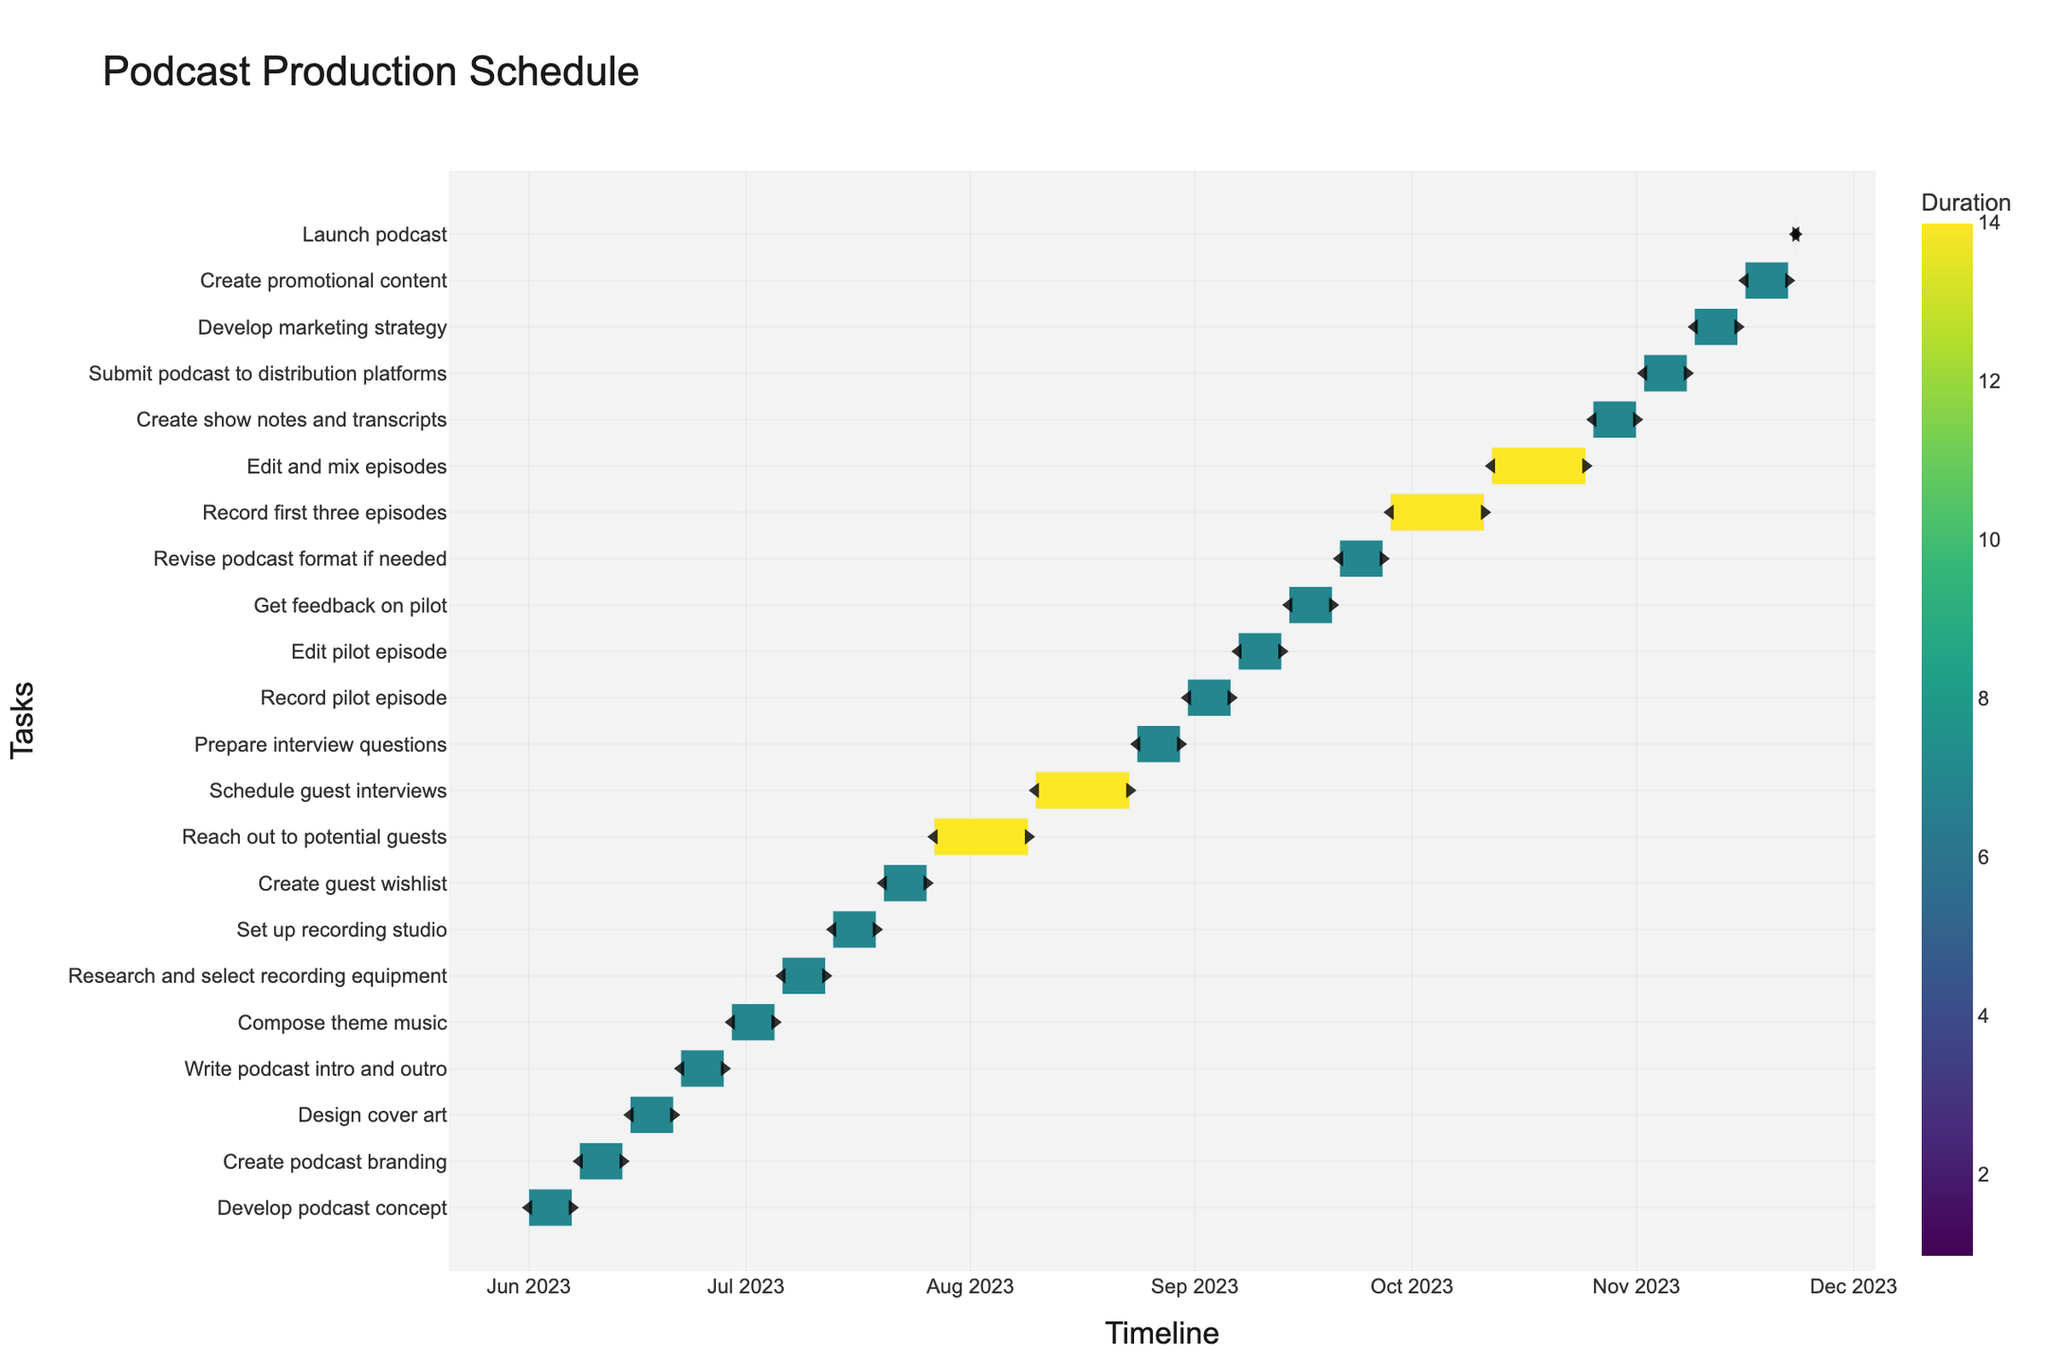What is the title of the chart? The title is displayed at the top of the Gantt chart, showing the main purpose of the chart, which in this case is related to a podcast production schedule.
Answer: Podcast Production Schedule How long is the "Develop podcast concept" phase? The duration can be calculated using the start and end dates of the task. For "Develop podcast concept," it starts on June 1, 2023, and ends on June 7, 2023. So the duration is 7 days.
Answer: 7 days What is the color scale used in the chart? The chart uses a sequential color scale named Viridis, typically ranging from dark blue to bright yellow, representing the duration of tasks.
Answer: Viridis Find the task that takes the longest time. How many days does it take? To find the task with the longest duration, we need to compare the durations of all tasks. "Reach out to potential guests" takes the longest duration starting from July 27, 2023, to August 9, 2023, which is 14 days.
Answer: 14 days Compare the duration of "Record pilot episode" and "Edit pilot episode." Which one takes longer, and by how many days? "Record pilot episode" takes 7 days (August 31, 2023, to September 6, 2023), and "Edit pilot episode" takes 7 days (September 7, 2023, to September 13, 2023). Both take the same amount of time, so there is no difference in their duration.
Answer: They take the same duration, 0 days difference What are the start and end dates of the first task on the chart? The first task is "Develop podcast concept," which starts on June 1, 2023, and ends on June 7, 2023.
Answer: June 1, 2023, to June 7, 2023 Identify the tasks associated with recording activities and their durations. The recording activities include "Record pilot episode," "Record first three episodes," and they span from August 31, 2023, to September 6, 2023, (7 days) and September 28, 2023, to October 11, 2023, (14 days) respectively.
Answer: Record pilot episode (7 days), Record first three episodes (14 days) Calculate the total duration needed for reaching out, scheduling, and preparing for guests. "Reach out to potential guests" (14 days) + "Schedule guest interviews" (14 days) + "Prepare interview questions" (7 days) = 35 days.
Answer: 35 days Which task directly precedes the "Launch podcast"? "Create promotional content" is the task directly preceding the "Launch podcast," as it ends on November 22, 2023, and the podcast launches on November 23, 2023.
Answer: Create promotional content What is the timeline range shown in the chart? The overall timeline range can be observed from the Gantt chart by looking at the first and last task dates. It ranges from June 1, 2023, to November 23, 2023.
Answer: June 1, 2023, to November 23, 2023 